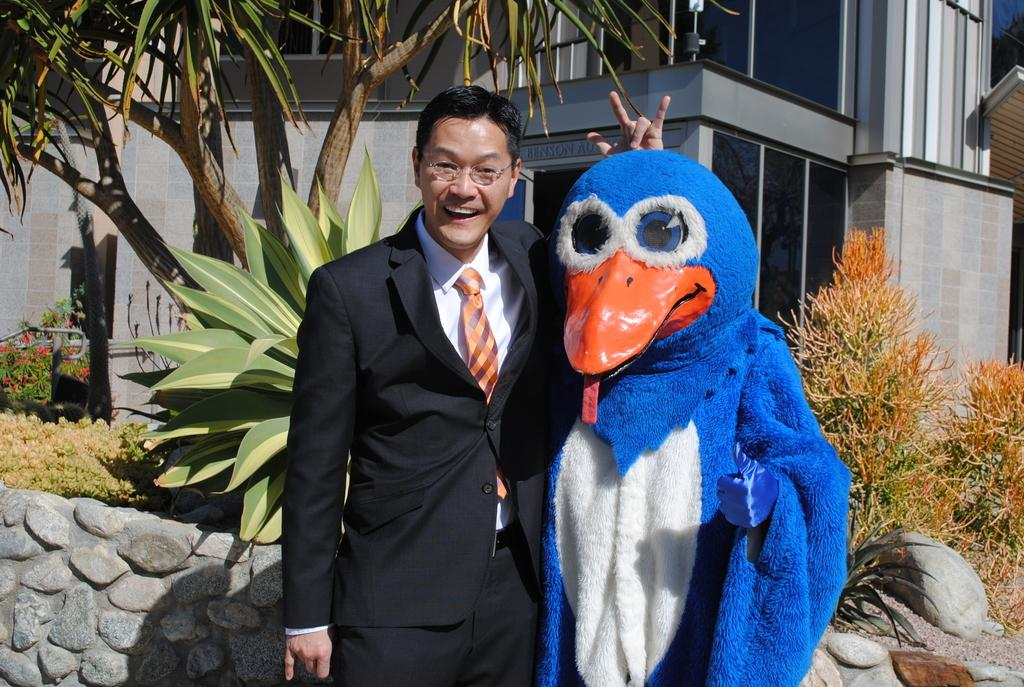Where was the image taken? The image was clicked outside. What is the main subject of the image? There is a person in the middle of the image. Can you describe the appearance of the second person in the image? There is another person wearing a mask in the image. What can be seen in the background of the image? There are trees and a building behind the people. What type of brick is used to make the soup in the image? There is no brick or soup present in the image. What kind of experience can be gained from the image? The image itself does not provide an experience, but it can be used to observe and describe the scene depicted. 